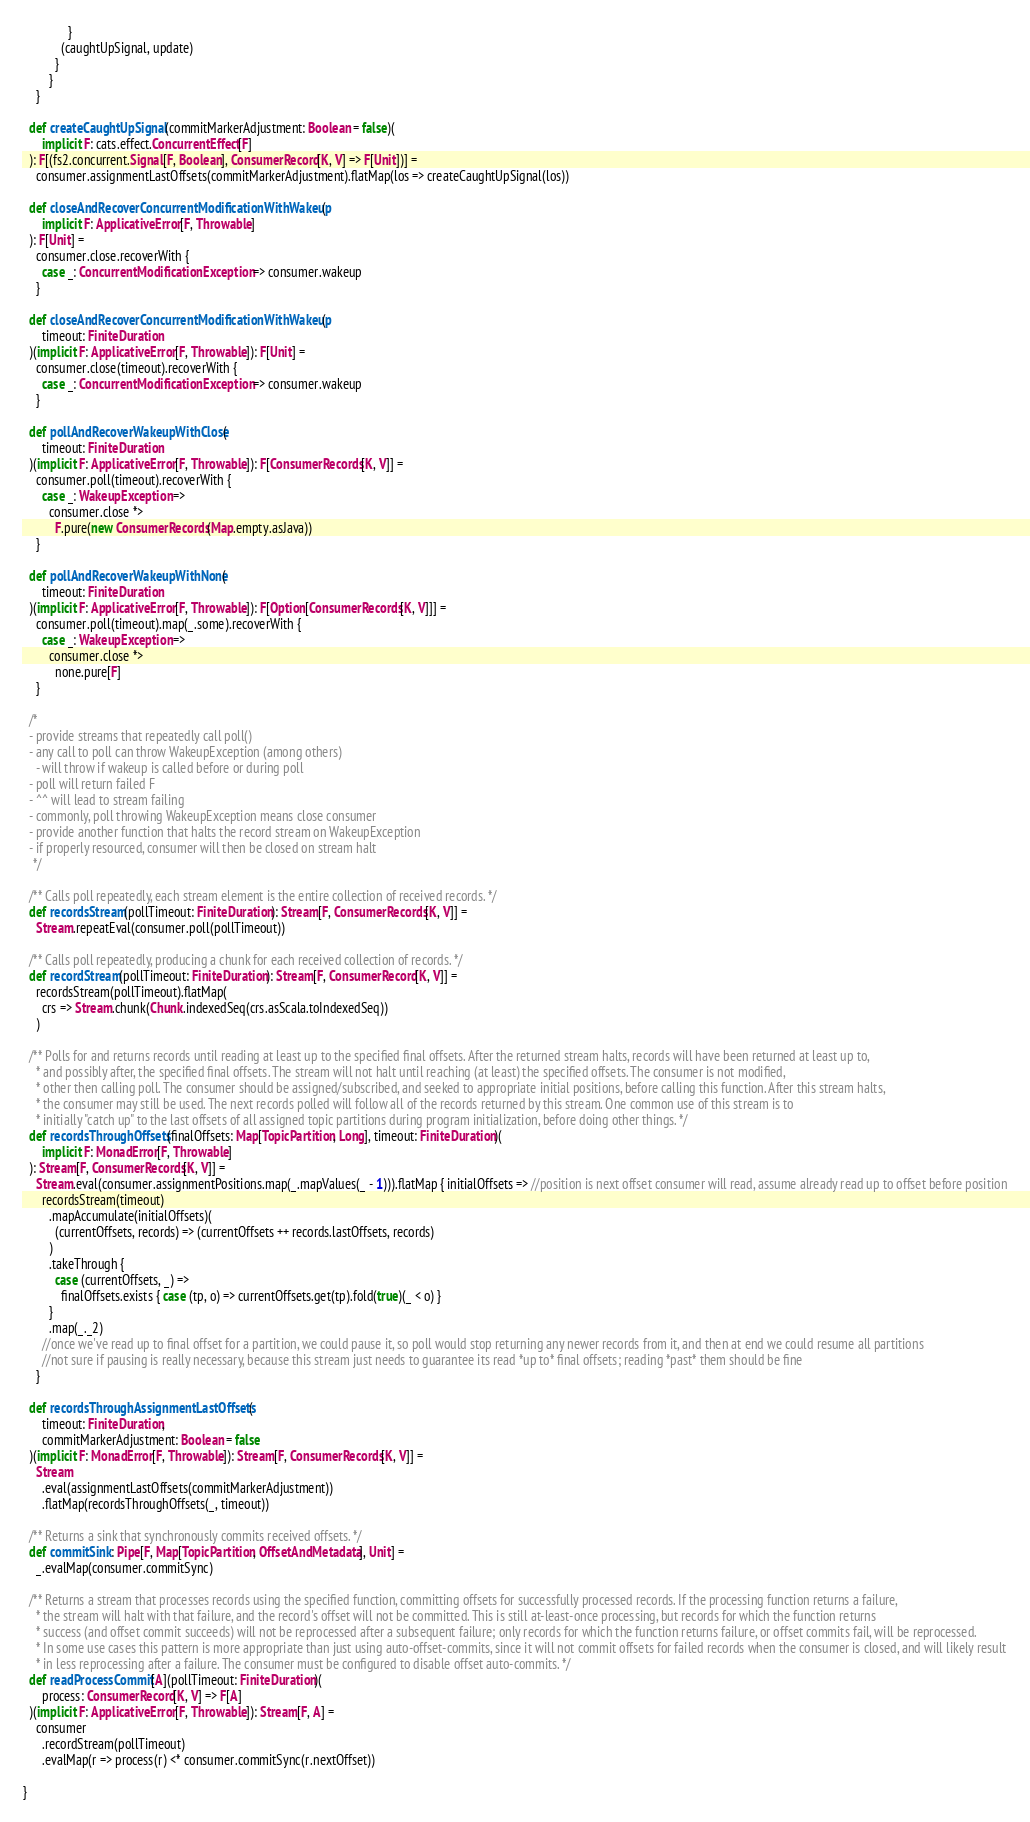Convert code to text. <code><loc_0><loc_0><loc_500><loc_500><_Scala_>              }
            (caughtUpSignal, update)
          }
        }
    }

  def createCaughtUpSignal(commitMarkerAdjustment: Boolean = false)(
      implicit F: cats.effect.ConcurrentEffect[F]
  ): F[(fs2.concurrent.Signal[F, Boolean], ConsumerRecord[K, V] => F[Unit])] =
    consumer.assignmentLastOffsets(commitMarkerAdjustment).flatMap(los => createCaughtUpSignal(los))

  def closeAndRecoverConcurrentModificationWithWakeup(
      implicit F: ApplicativeError[F, Throwable]
  ): F[Unit] =
    consumer.close.recoverWith {
      case _: ConcurrentModificationException => consumer.wakeup
    }

  def closeAndRecoverConcurrentModificationWithWakeup(
      timeout: FiniteDuration
  )(implicit F: ApplicativeError[F, Throwable]): F[Unit] =
    consumer.close(timeout).recoverWith {
      case _: ConcurrentModificationException => consumer.wakeup
    }

  def pollAndRecoverWakeupWithClose(
      timeout: FiniteDuration
  )(implicit F: ApplicativeError[F, Throwable]): F[ConsumerRecords[K, V]] =
    consumer.poll(timeout).recoverWith {
      case _: WakeupException =>
        consumer.close *>
          F.pure(new ConsumerRecords(Map.empty.asJava))
    }

  def pollAndRecoverWakeupWithNone(
      timeout: FiniteDuration
  )(implicit F: ApplicativeError[F, Throwable]): F[Option[ConsumerRecords[K, V]]] =
    consumer.poll(timeout).map(_.some).recoverWith {
      case _: WakeupException =>
        consumer.close *>
          none.pure[F]
    }

  /*
  - provide streams that repeatedly call poll()
  - any call to poll can throw WakeupException (among others)
    - will throw if wakeup is called before or during poll
  - poll will return failed F
  - ^^ will lead to stream failing
  - commonly, poll throwing WakeupException means close consumer
  - provide another function that halts the record stream on WakeupException
  - if properly resourced, consumer will then be closed on stream halt
   */

  /** Calls poll repeatedly, each stream element is the entire collection of received records. */
  def recordsStream(pollTimeout: FiniteDuration): Stream[F, ConsumerRecords[K, V]] =
    Stream.repeatEval(consumer.poll(pollTimeout))

  /** Calls poll repeatedly, producing a chunk for each received collection of records. */
  def recordStream(pollTimeout: FiniteDuration): Stream[F, ConsumerRecord[K, V]] =
    recordsStream(pollTimeout).flatMap(
      crs => Stream.chunk(Chunk.indexedSeq(crs.asScala.toIndexedSeq))
    )

  /** Polls for and returns records until reading at least up to the specified final offsets. After the returned stream halts, records will have been returned at least up to,
    * and possibly after, the specified final offsets. The stream will not halt until reaching (at least) the specified offsets. The consumer is not modified,
    * other then calling poll. The consumer should be assigned/subscribed, and seeked to appropriate initial positions, before calling this function. After this stream halts,
    * the consumer may still be used. The next records polled will follow all of the records returned by this stream. One common use of this stream is to
    * initially "catch up" to the last offsets of all assigned topic partitions during program initialization, before doing other things. */
  def recordsThroughOffsets(finalOffsets: Map[TopicPartition, Long], timeout: FiniteDuration)(
      implicit F: MonadError[F, Throwable]
  ): Stream[F, ConsumerRecords[K, V]] =
    Stream.eval(consumer.assignmentPositions.map(_.mapValues(_ - 1))).flatMap { initialOffsets => //position is next offset consumer will read, assume already read up to offset before position
      recordsStream(timeout)
        .mapAccumulate(initialOffsets)(
          (currentOffsets, records) => (currentOffsets ++ records.lastOffsets, records)
        )
        .takeThrough {
          case (currentOffsets, _) =>
            finalOffsets.exists { case (tp, o) => currentOffsets.get(tp).fold(true)(_ < o) }
        }
        .map(_._2)
      //once we've read up to final offset for a partition, we could pause it, so poll would stop returning any newer records from it, and then at end we could resume all partitions
      //not sure if pausing is really necessary, because this stream just needs to guarantee its read *up to* final offsets; reading *past* them should be fine
    }

  def recordsThroughAssignmentLastOffsets(
      timeout: FiniteDuration,
      commitMarkerAdjustment: Boolean = false
  )(implicit F: MonadError[F, Throwable]): Stream[F, ConsumerRecords[K, V]] =
    Stream
      .eval(assignmentLastOffsets(commitMarkerAdjustment))
      .flatMap(recordsThroughOffsets(_, timeout))

  /** Returns a sink that synchronously commits received offsets. */
  def commitSink: Pipe[F, Map[TopicPartition, OffsetAndMetadata], Unit] =
    _.evalMap(consumer.commitSync)

  /** Returns a stream that processes records using the specified function, committing offsets for successfully processed records. If the processing function returns a failure,
    * the stream will halt with that failure, and the record's offset will not be committed. This is still at-least-once processing, but records for which the function returns
    * success (and offset commit succeeds) will not be reprocessed after a subsequent failure; only records for which the function returns failure, or offset commits fail, will be reprocessed.
    * In some use cases this pattern is more appropriate than just using auto-offset-commits, since it will not commit offsets for failed records when the consumer is closed, and will likely result
    * in less reprocessing after a failure. The consumer must be configured to disable offset auto-commits. */
  def readProcessCommit[A](pollTimeout: FiniteDuration)(
      process: ConsumerRecord[K, V] => F[A]
  )(implicit F: ApplicativeError[F, Throwable]): Stream[F, A] =
    consumer
      .recordStream(pollTimeout)
      .evalMap(r => process(r) <* consumer.commitSync(r.nextOffset))

}
</code> 